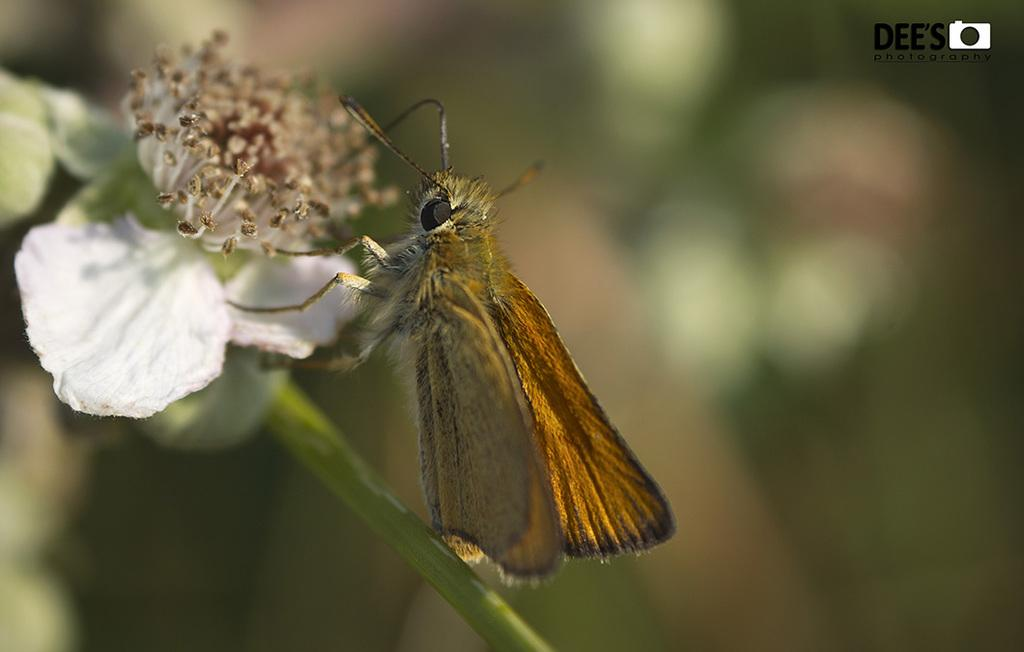What is the main subject of the image? There is a butterfly in the image. Where is the butterfly located in the image? The butterfly is sitting on a stem. What other floral element is present in the image? There is a flower in the image. Can you describe the background of the image? The background of the image is blurred. What country is the butterfly from in the image? The image does not provide information about the butterfly's origin or country. How many bubbles are surrounding the butterfly in the image? There are no bubbles present in the image; it features a butterfly sitting on a stem with a flower in the background. 